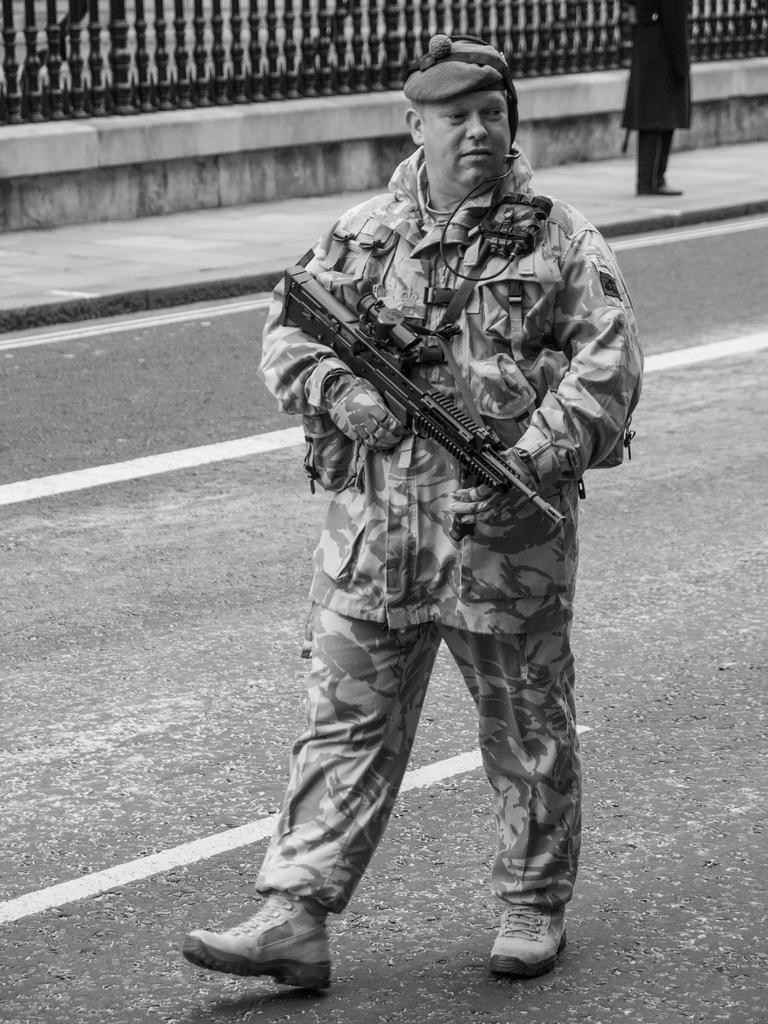What is the main subject in the center of the image? There is a cop in the center of the image. What is the cop holding in his hand? The cop is holding a gun in his hand. Are there any other people in the image besides the cop? Yes, there is another person in the image. What can be seen at the top side of the image? There is a boundary at the top side of the image. What color is the crayon being used by the cop in the image? There is no crayon present in the image; the cop is holding a gun. What is the weather like on the day the image was taken? The provided facts do not mention the weather or the day the image was taken, so it cannot be determined from the image. 